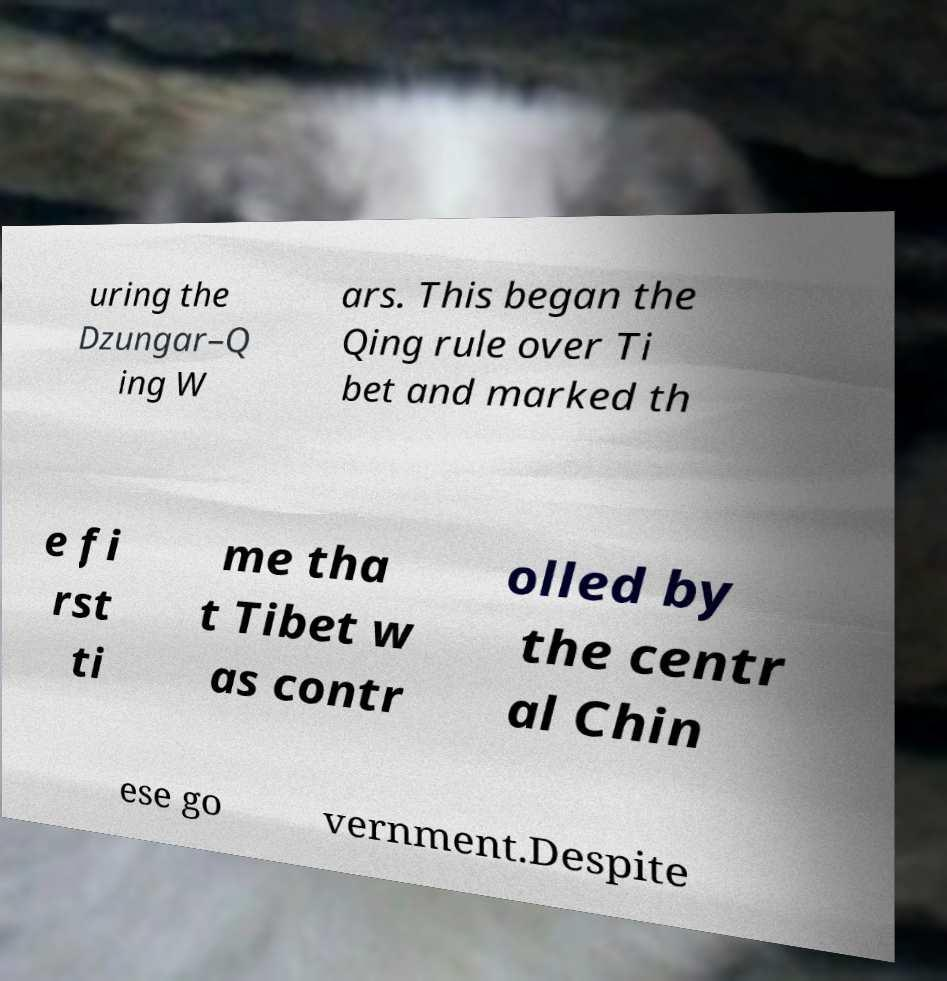What messages or text are displayed in this image? I need them in a readable, typed format. uring the Dzungar–Q ing W ars. This began the Qing rule over Ti bet and marked th e fi rst ti me tha t Tibet w as contr olled by the centr al Chin ese go vernment.Despite 